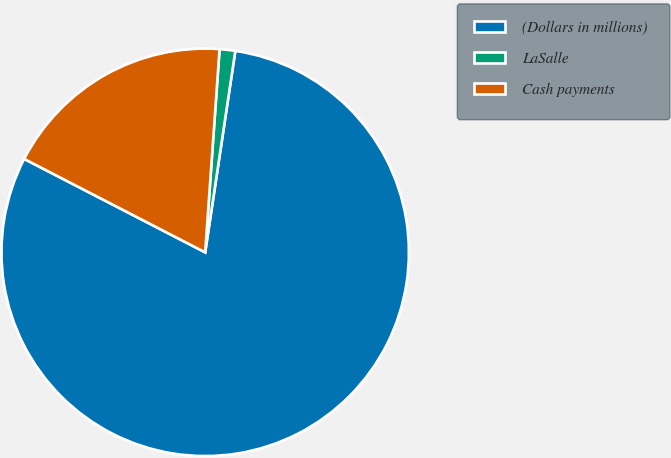<chart> <loc_0><loc_0><loc_500><loc_500><pie_chart><fcel>(Dollars in millions)<fcel>LaSalle<fcel>Cash payments<nl><fcel>80.22%<fcel>1.24%<fcel>18.54%<nl></chart> 